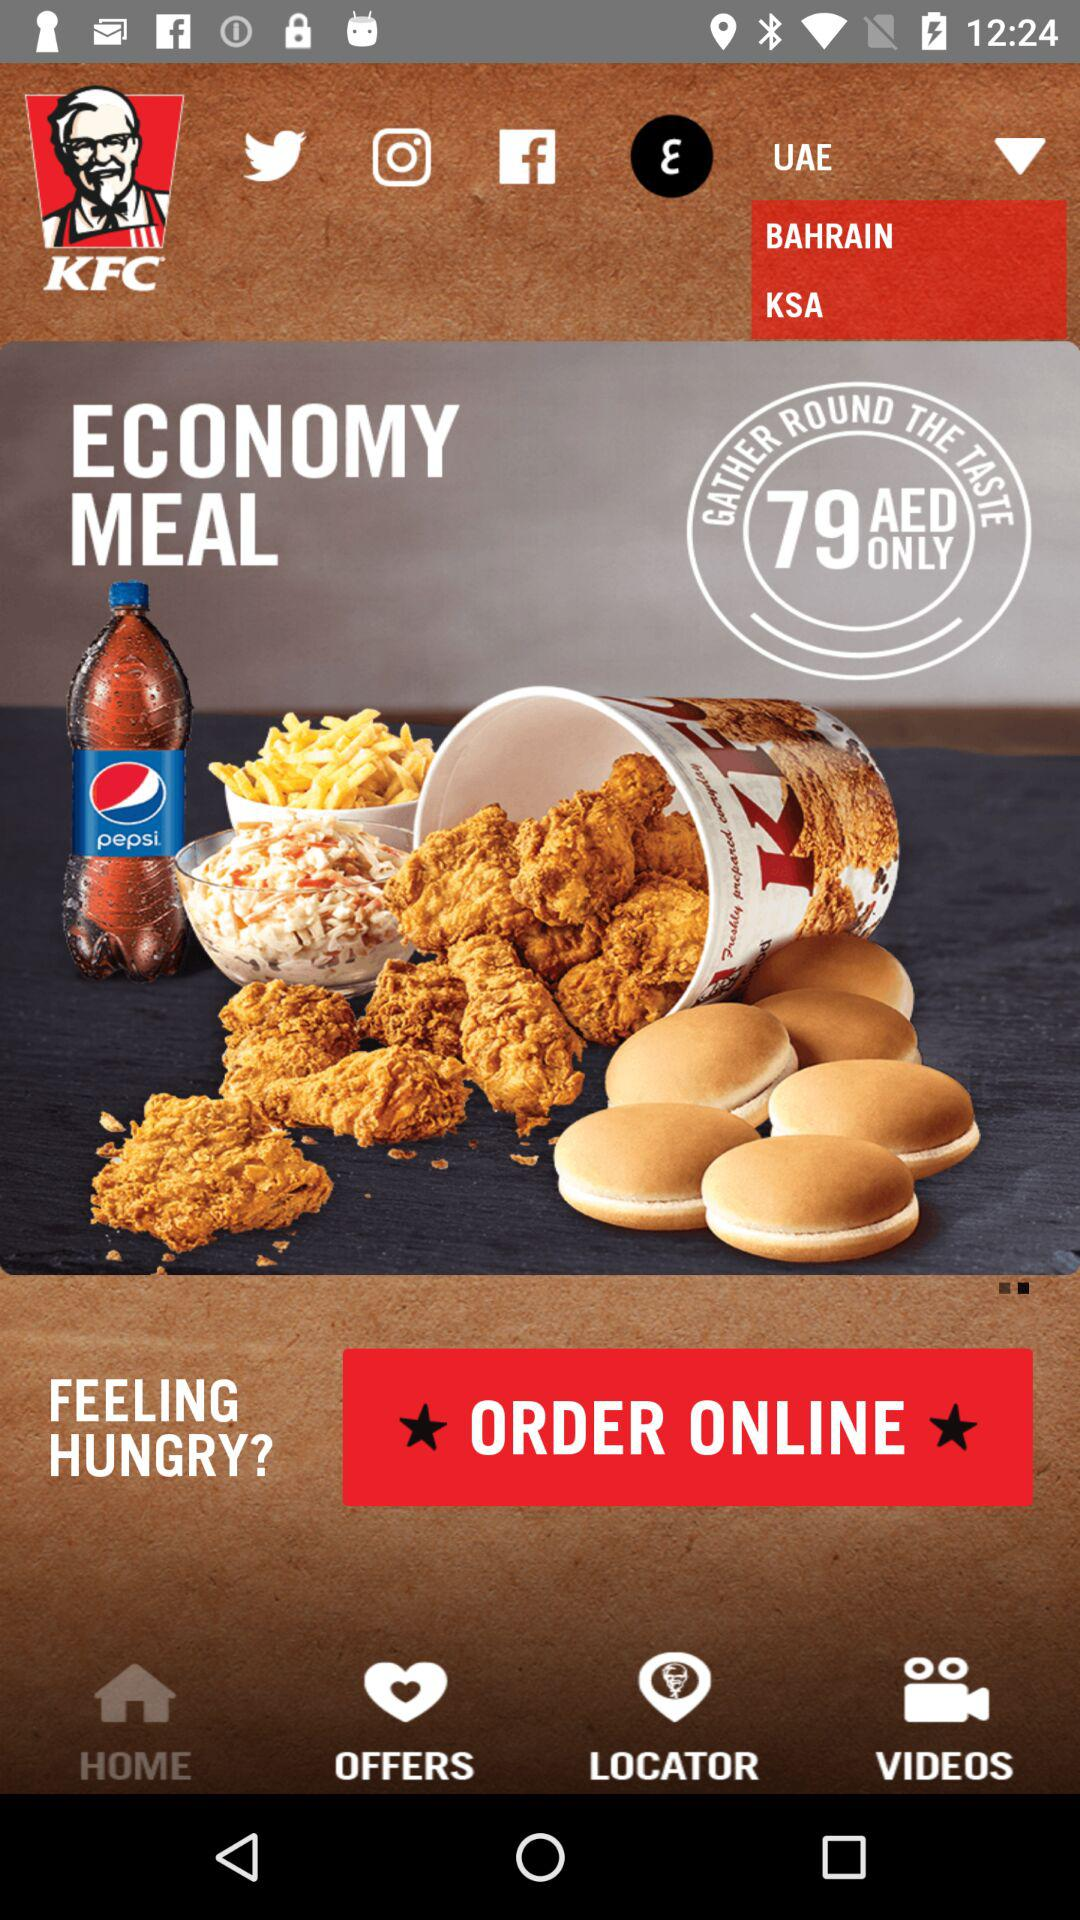Which location is selected? The selected location is UAE. 